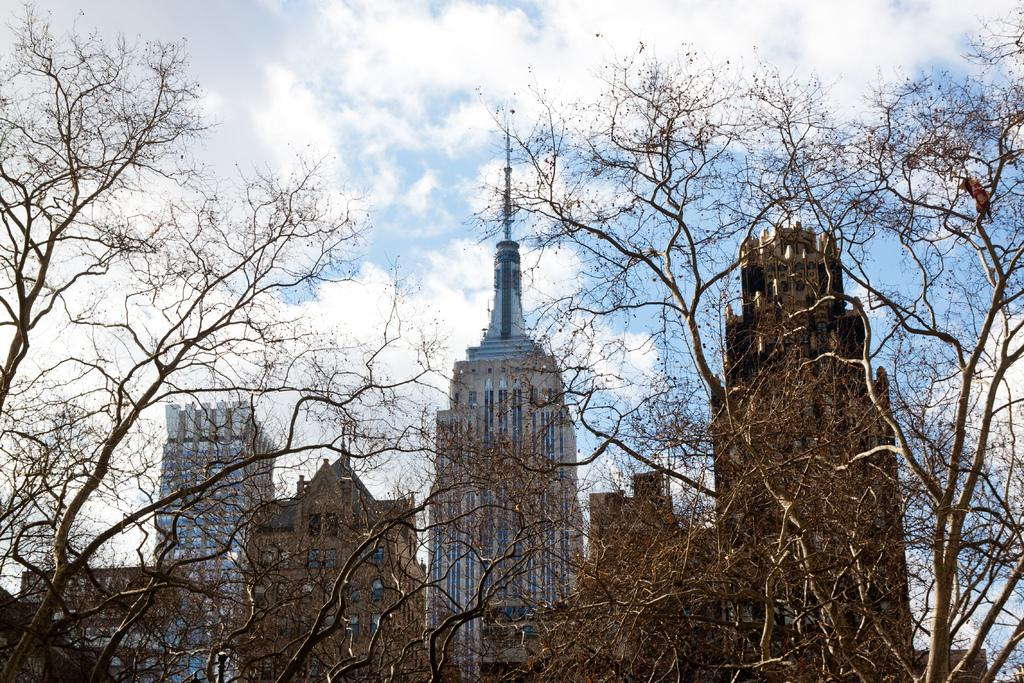What type of vegetation is visible in the front of the image? There are trees in the front of the image. What type of structures can be seen in the background of the image? There are buildings in the background of the image. What is visible in the sky in the background of the image? The sky is visible in the background of the image. What type of potato is being used as an engine in the image? There is no potato or engine present in the image. What type of boundary can be seen in the image? There is no boundary visible in the image; it features trees in the front and buildings in the background. 